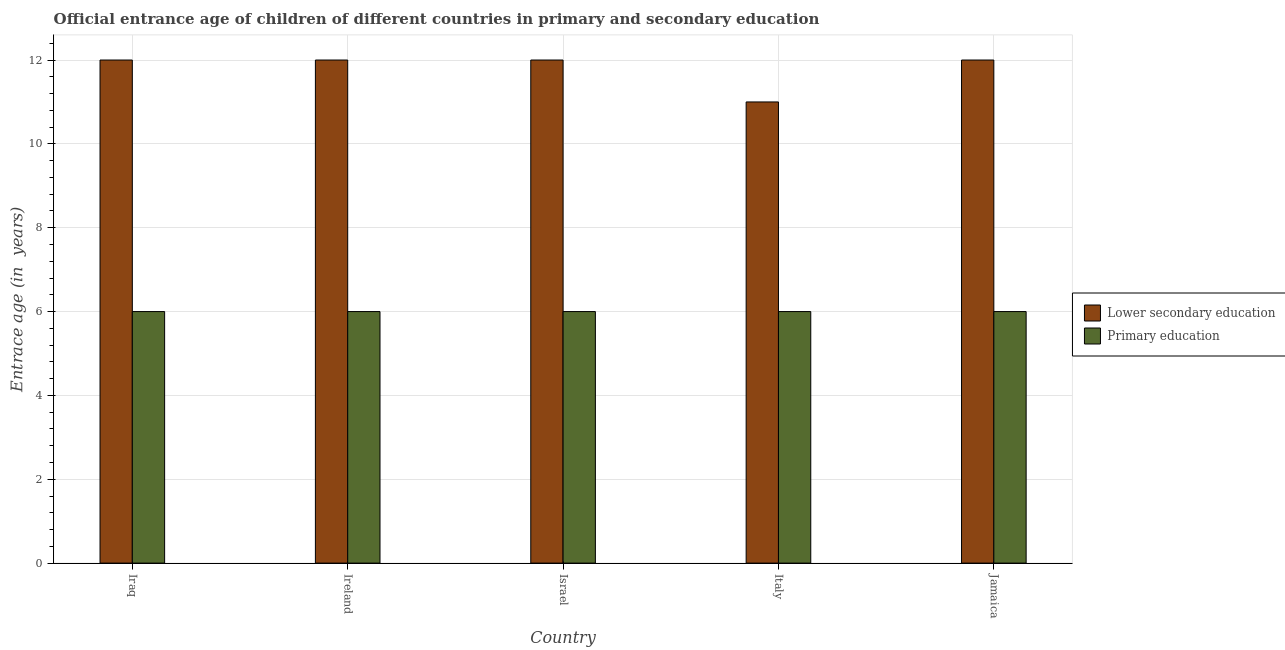How many different coloured bars are there?
Make the answer very short. 2. Are the number of bars per tick equal to the number of legend labels?
Your response must be concise. Yes. Are the number of bars on each tick of the X-axis equal?
Offer a terse response. Yes. How many bars are there on the 1st tick from the left?
Keep it short and to the point. 2. What is the entrance age of children in lower secondary education in Jamaica?
Provide a succinct answer. 12. Across all countries, what is the maximum entrance age of children in lower secondary education?
Provide a short and direct response. 12. Across all countries, what is the minimum entrance age of children in lower secondary education?
Make the answer very short. 11. In which country was the entrance age of children in lower secondary education maximum?
Offer a terse response. Iraq. In which country was the entrance age of chiildren in primary education minimum?
Your answer should be very brief. Iraq. What is the total entrance age of children in lower secondary education in the graph?
Ensure brevity in your answer.  59. What is the difference between the entrance age of children in lower secondary education in Iraq and that in Italy?
Provide a succinct answer. 1. What is the difference between the entrance age of chiildren in primary education in Italy and the entrance age of children in lower secondary education in Israel?
Your answer should be compact. -6. What is the difference between the entrance age of chiildren in primary education and entrance age of children in lower secondary education in Israel?
Offer a very short reply. -6. What is the difference between the highest and the second highest entrance age of children in lower secondary education?
Provide a short and direct response. 0. What is the difference between the highest and the lowest entrance age of chiildren in primary education?
Ensure brevity in your answer.  0. In how many countries, is the entrance age of children in lower secondary education greater than the average entrance age of children in lower secondary education taken over all countries?
Make the answer very short. 4. Is the sum of the entrance age of chiildren in primary education in Israel and Italy greater than the maximum entrance age of children in lower secondary education across all countries?
Your response must be concise. No. What does the 1st bar from the left in Ireland represents?
Give a very brief answer. Lower secondary education. How many bars are there?
Your answer should be very brief. 10. What is the difference between two consecutive major ticks on the Y-axis?
Your response must be concise. 2. Are the values on the major ticks of Y-axis written in scientific E-notation?
Provide a short and direct response. No. Does the graph contain any zero values?
Provide a short and direct response. No. Does the graph contain grids?
Your response must be concise. Yes. How many legend labels are there?
Give a very brief answer. 2. What is the title of the graph?
Your answer should be compact. Official entrance age of children of different countries in primary and secondary education. What is the label or title of the Y-axis?
Offer a very short reply. Entrace age (in  years). What is the Entrace age (in  years) in Lower secondary education in Iraq?
Offer a terse response. 12. What is the Entrace age (in  years) in Primary education in Ireland?
Offer a terse response. 6. What is the Entrace age (in  years) of Primary education in Israel?
Your answer should be compact. 6. What is the Entrace age (in  years) in Lower secondary education in Jamaica?
Provide a short and direct response. 12. What is the Entrace age (in  years) in Primary education in Jamaica?
Your answer should be compact. 6. Across all countries, what is the maximum Entrace age (in  years) in Primary education?
Provide a short and direct response. 6. Across all countries, what is the minimum Entrace age (in  years) of Lower secondary education?
Offer a very short reply. 11. Across all countries, what is the minimum Entrace age (in  years) of Primary education?
Provide a short and direct response. 6. What is the total Entrace age (in  years) of Lower secondary education in the graph?
Your response must be concise. 59. What is the total Entrace age (in  years) of Primary education in the graph?
Make the answer very short. 30. What is the difference between the Entrace age (in  years) of Primary education in Iraq and that in Ireland?
Offer a terse response. 0. What is the difference between the Entrace age (in  years) of Lower secondary education in Iraq and that in Israel?
Your answer should be very brief. 0. What is the difference between the Entrace age (in  years) of Primary education in Iraq and that in Italy?
Your answer should be very brief. 0. What is the difference between the Entrace age (in  years) in Lower secondary education in Iraq and that in Jamaica?
Your answer should be very brief. 0. What is the difference between the Entrace age (in  years) in Lower secondary education in Ireland and that in Italy?
Ensure brevity in your answer.  1. What is the difference between the Entrace age (in  years) of Primary education in Ireland and that in Italy?
Give a very brief answer. 0. What is the difference between the Entrace age (in  years) in Lower secondary education in Ireland and that in Jamaica?
Keep it short and to the point. 0. What is the difference between the Entrace age (in  years) of Primary education in Ireland and that in Jamaica?
Your answer should be very brief. 0. What is the difference between the Entrace age (in  years) in Primary education in Israel and that in Italy?
Offer a terse response. 0. What is the difference between the Entrace age (in  years) of Lower secondary education in Israel and that in Jamaica?
Ensure brevity in your answer.  0. What is the difference between the Entrace age (in  years) in Primary education in Israel and that in Jamaica?
Offer a very short reply. 0. What is the difference between the Entrace age (in  years) of Lower secondary education in Italy and that in Jamaica?
Keep it short and to the point. -1. What is the difference between the Entrace age (in  years) in Lower secondary education in Iraq and the Entrace age (in  years) in Primary education in Ireland?
Ensure brevity in your answer.  6. What is the difference between the Entrace age (in  years) of Lower secondary education in Iraq and the Entrace age (in  years) of Primary education in Israel?
Your answer should be very brief. 6. What is the difference between the Entrace age (in  years) of Lower secondary education in Iraq and the Entrace age (in  years) of Primary education in Italy?
Offer a very short reply. 6. What is the difference between the Entrace age (in  years) in Lower secondary education in Iraq and the Entrace age (in  years) in Primary education in Jamaica?
Provide a short and direct response. 6. What is the difference between the Entrace age (in  years) of Lower secondary education in Ireland and the Entrace age (in  years) of Primary education in Israel?
Make the answer very short. 6. What is the difference between the Entrace age (in  years) in Lower secondary education in Ireland and the Entrace age (in  years) in Primary education in Italy?
Your answer should be compact. 6. What is the difference between the Entrace age (in  years) of Lower secondary education in Israel and the Entrace age (in  years) of Primary education in Jamaica?
Provide a succinct answer. 6. What is the difference between the Entrace age (in  years) in Lower secondary education in Italy and the Entrace age (in  years) in Primary education in Jamaica?
Provide a succinct answer. 5. What is the difference between the Entrace age (in  years) in Lower secondary education and Entrace age (in  years) in Primary education in Iraq?
Give a very brief answer. 6. What is the difference between the Entrace age (in  years) of Lower secondary education and Entrace age (in  years) of Primary education in Italy?
Your response must be concise. 5. What is the ratio of the Entrace age (in  years) in Lower secondary education in Iraq to that in Ireland?
Make the answer very short. 1. What is the ratio of the Entrace age (in  years) in Primary education in Iraq to that in Ireland?
Your answer should be very brief. 1. What is the ratio of the Entrace age (in  years) in Lower secondary education in Iraq to that in Israel?
Make the answer very short. 1. What is the ratio of the Entrace age (in  years) of Lower secondary education in Iraq to that in Italy?
Offer a very short reply. 1.09. What is the ratio of the Entrace age (in  years) in Primary education in Iraq to that in Italy?
Your answer should be very brief. 1. What is the ratio of the Entrace age (in  years) of Lower secondary education in Iraq to that in Jamaica?
Make the answer very short. 1. What is the ratio of the Entrace age (in  years) in Lower secondary education in Ireland to that in Israel?
Provide a short and direct response. 1. What is the ratio of the Entrace age (in  years) in Primary education in Ireland to that in Israel?
Make the answer very short. 1. What is the ratio of the Entrace age (in  years) in Lower secondary education in Ireland to that in Italy?
Make the answer very short. 1.09. What is the ratio of the Entrace age (in  years) in Primary education in Israel to that in Italy?
Give a very brief answer. 1. What is the ratio of the Entrace age (in  years) of Primary education in Israel to that in Jamaica?
Provide a short and direct response. 1. What is the ratio of the Entrace age (in  years) in Lower secondary education in Italy to that in Jamaica?
Provide a short and direct response. 0.92. What is the difference between the highest and the second highest Entrace age (in  years) in Lower secondary education?
Make the answer very short. 0. What is the difference between the highest and the lowest Entrace age (in  years) in Lower secondary education?
Ensure brevity in your answer.  1. 